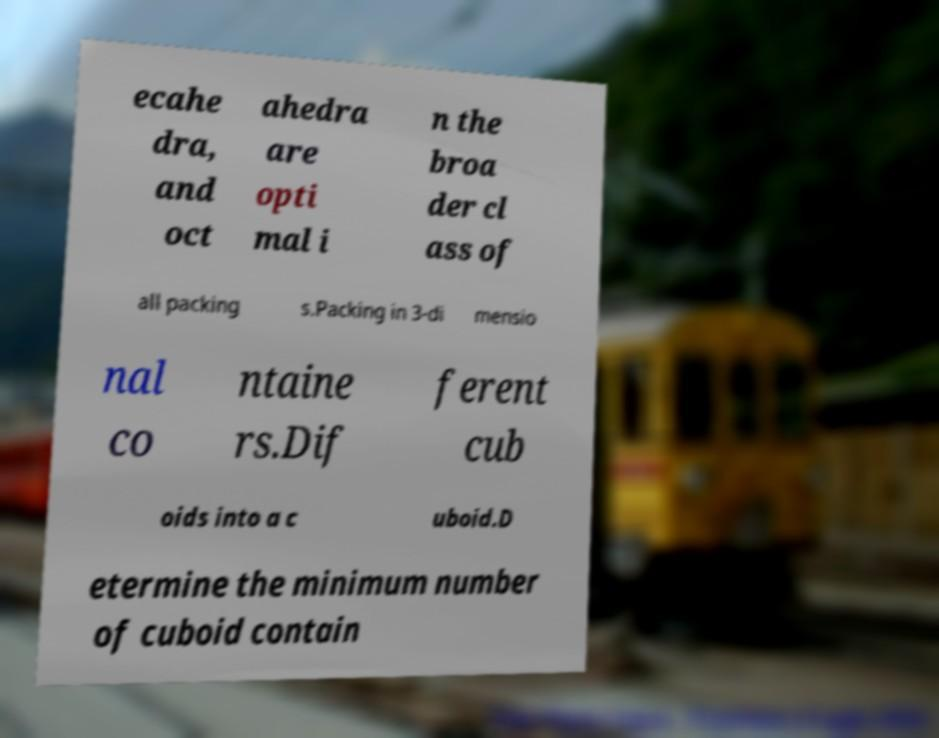I need the written content from this picture converted into text. Can you do that? ecahe dra, and oct ahedra are opti mal i n the broa der cl ass of all packing s.Packing in 3-di mensio nal co ntaine rs.Dif ferent cub oids into a c uboid.D etermine the minimum number of cuboid contain 